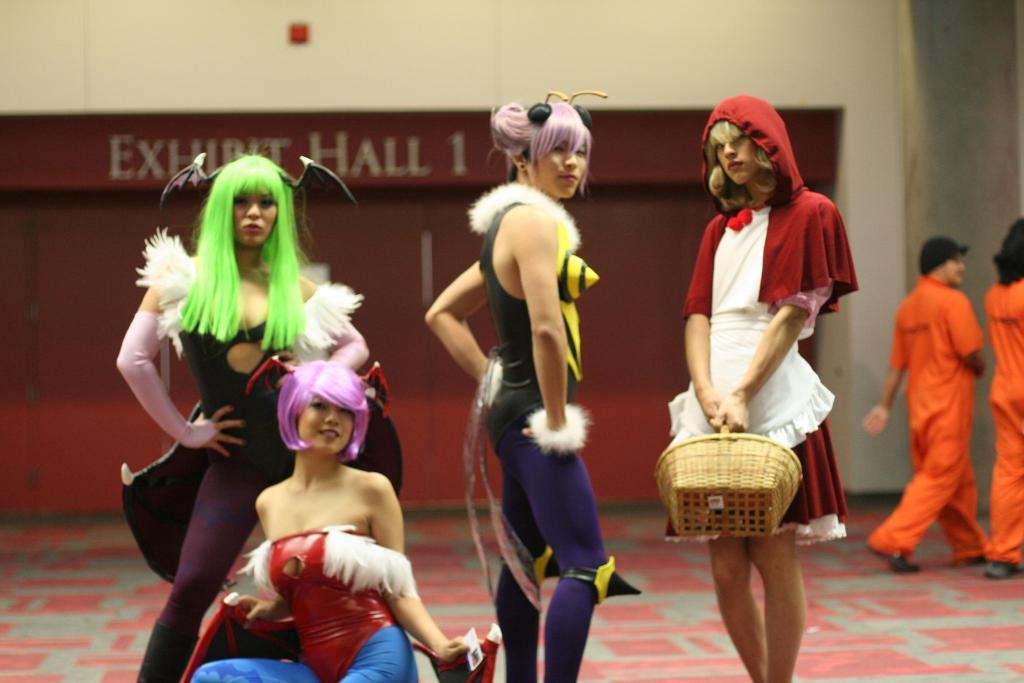How would you summarize this image in a sentence or two? In this image we can see four people. We can also see the person holding the basket and standing. In the background we can see two people walking on the path. We can also see the wall, floor and also the text on the wall. 